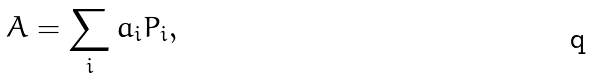Convert formula to latex. <formula><loc_0><loc_0><loc_500><loc_500>A = \sum _ { i } a _ { i } P _ { i } ,</formula> 